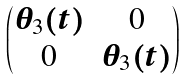Convert formula to latex. <formula><loc_0><loc_0><loc_500><loc_500>\begin{pmatrix} \theta _ { 3 } ( t ) & 0 \\ 0 & \theta _ { 3 } ( t ) \end{pmatrix}</formula> 